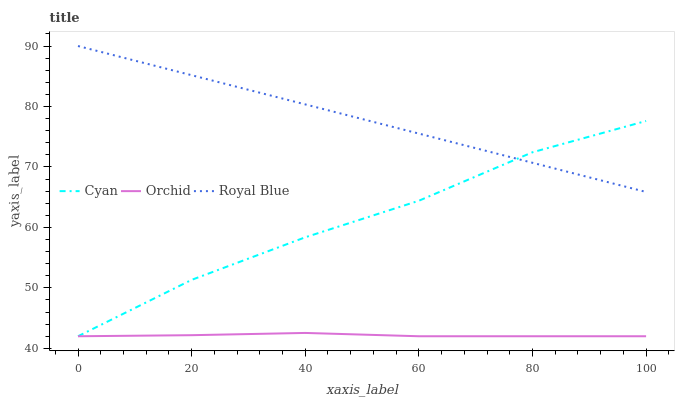Does Orchid have the minimum area under the curve?
Answer yes or no. Yes. Does Royal Blue have the maximum area under the curve?
Answer yes or no. Yes. Does Royal Blue have the minimum area under the curve?
Answer yes or no. No. Does Orchid have the maximum area under the curve?
Answer yes or no. No. Is Royal Blue the smoothest?
Answer yes or no. Yes. Is Cyan the roughest?
Answer yes or no. Yes. Is Orchid the smoothest?
Answer yes or no. No. Is Orchid the roughest?
Answer yes or no. No. Does Cyan have the lowest value?
Answer yes or no. Yes. Does Royal Blue have the lowest value?
Answer yes or no. No. Does Royal Blue have the highest value?
Answer yes or no. Yes. Does Orchid have the highest value?
Answer yes or no. No. Is Orchid less than Royal Blue?
Answer yes or no. Yes. Is Royal Blue greater than Orchid?
Answer yes or no. Yes. Does Orchid intersect Cyan?
Answer yes or no. Yes. Is Orchid less than Cyan?
Answer yes or no. No. Is Orchid greater than Cyan?
Answer yes or no. No. Does Orchid intersect Royal Blue?
Answer yes or no. No. 